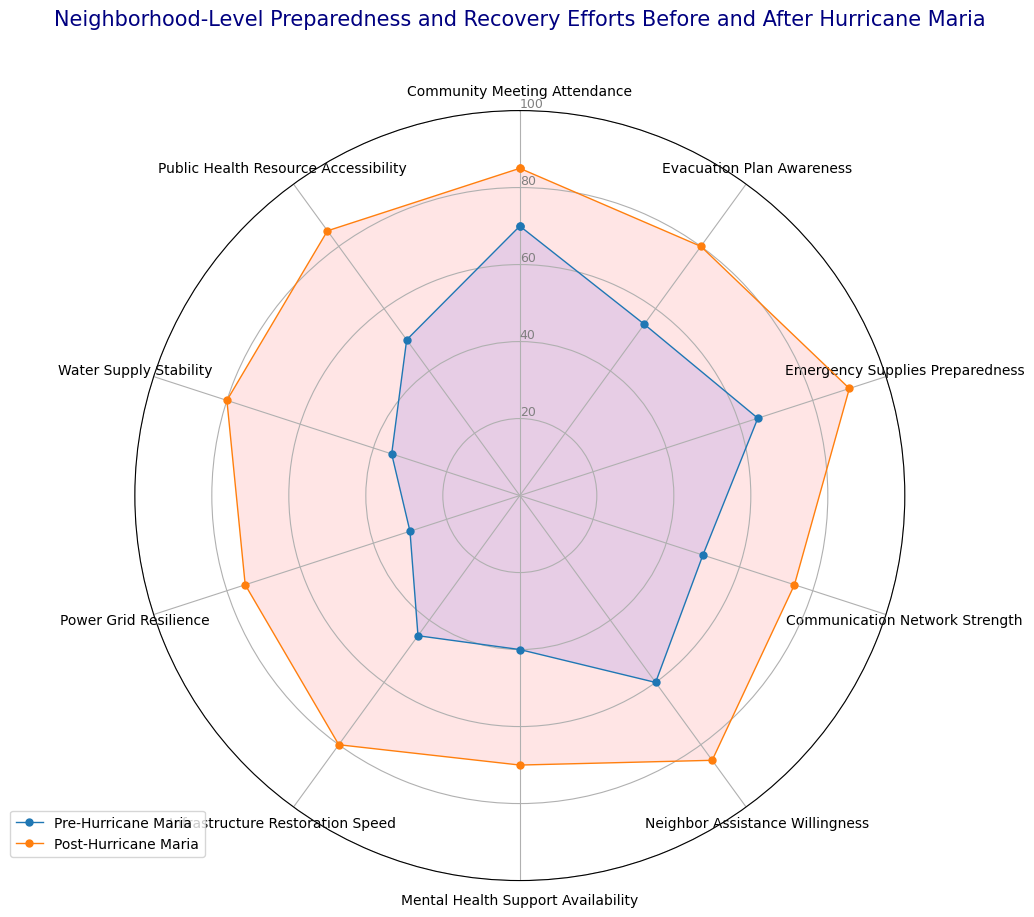What category saw the highest improvement from Pre-Hurricane Maria to Post-Hurricane Maria? First, identify the values before and after the hurricane for each category. Then calculate the difference for each. The category with the largest positive difference experienced the highest improvement. For instance, the Power Grid Resilience improved from 30 to 75, a 45-point increase which is the highest improvement noted in the data.
Answer: Power Grid Resilience Which category had the lowest preparedness level before Hurricane Maria? Examine the Pre-Hurricane Maria values for all categories and find the one with the lowest value. Power Grid Resilience had the lowest preparedness level of 30.
Answer: Power Grid Resilience How much did Neighborhood Assistance Willingness improve after Hurricane Maria? Check the Pre-Hurricane Maria and Post-Hurricane Maria values for Neighbor Assistance Willingness. The values are 60 and 85, respectively. Subtract the initial value from the final value: 85 - 60 = 25.
Answer: 25 Which category had the same value for Pre-Hurricane Maria and Post-Hurricane Maria? Look through the radar chart for any categories where the lines for Pre-Hurricane Maria and Post-Hurricane Maria intersect, indicating the same value before and after the hurricane. In this case, no category had the same value pre- and post-hurricane.
Answer: None Are more categories above 80 Post-Hurricane Maria than Pre-Hurricane Maria? Count the number of categories with values above 80 for both Pre-Hurricane Maria and Post-Hurricane Maria by scanning the radar chart. Post-Hurricane Maria has five categories (Community Meeting Attendance, Evacuation Plan Awareness, Emergency Supplies Preparedness, Infrastructure Restoration Speed, Neighbor Assistance Willingness, Water Supply Stability, Public Health Resource Accessibility) above 80, while Pre-Hurricane Maria has none above 80.
Answer: Yes What is the average value of all categories post-Hurricane Maria? Add all the Post-Hurricane Maria values and divide by the number of categories. The total is 85 + 80 + 90 + 75 + 85 + 70 + 80 + 75 + 80 + 85 = 805. There are 10 categories, so the average is 805 / 10 = 80.5.
Answer: 80.5 Which category had the smallest improvement from Pre-Hurricane Maria to Post-Hurricane Maria? Calculate the differences for each category between the two periods and find the smallest positive difference. Community Meeting Attendance improved by 85 - 70 = 15, the smallest improvement.
Answer: Community Meeting Attendance Did the Mental Health Support Availability see more than a 25-point increase? Calculate the change for Mental Health Support Availability from Pre to Post. The values are 40 and 70, respectively. 70 - 40 = 30, which is more than 25.
Answer: Yes 